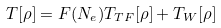Convert formula to latex. <formula><loc_0><loc_0><loc_500><loc_500>T [ \rho ] = F ( N _ { e } ) T _ { T F } [ \rho ] + T _ { W } [ \rho ]</formula> 